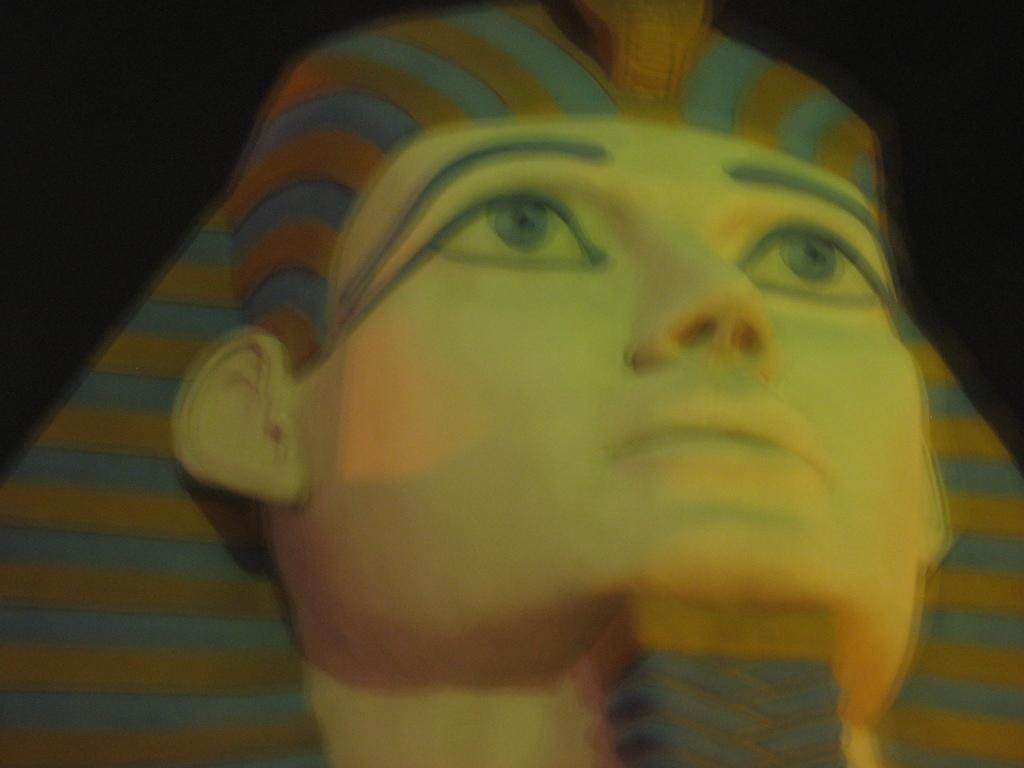What is the main subject in the image? There is a statue in the image. What type of shirt is the statue wearing in the image? The statue is not wearing a shirt, as it is a non-living object and does not have clothing. 